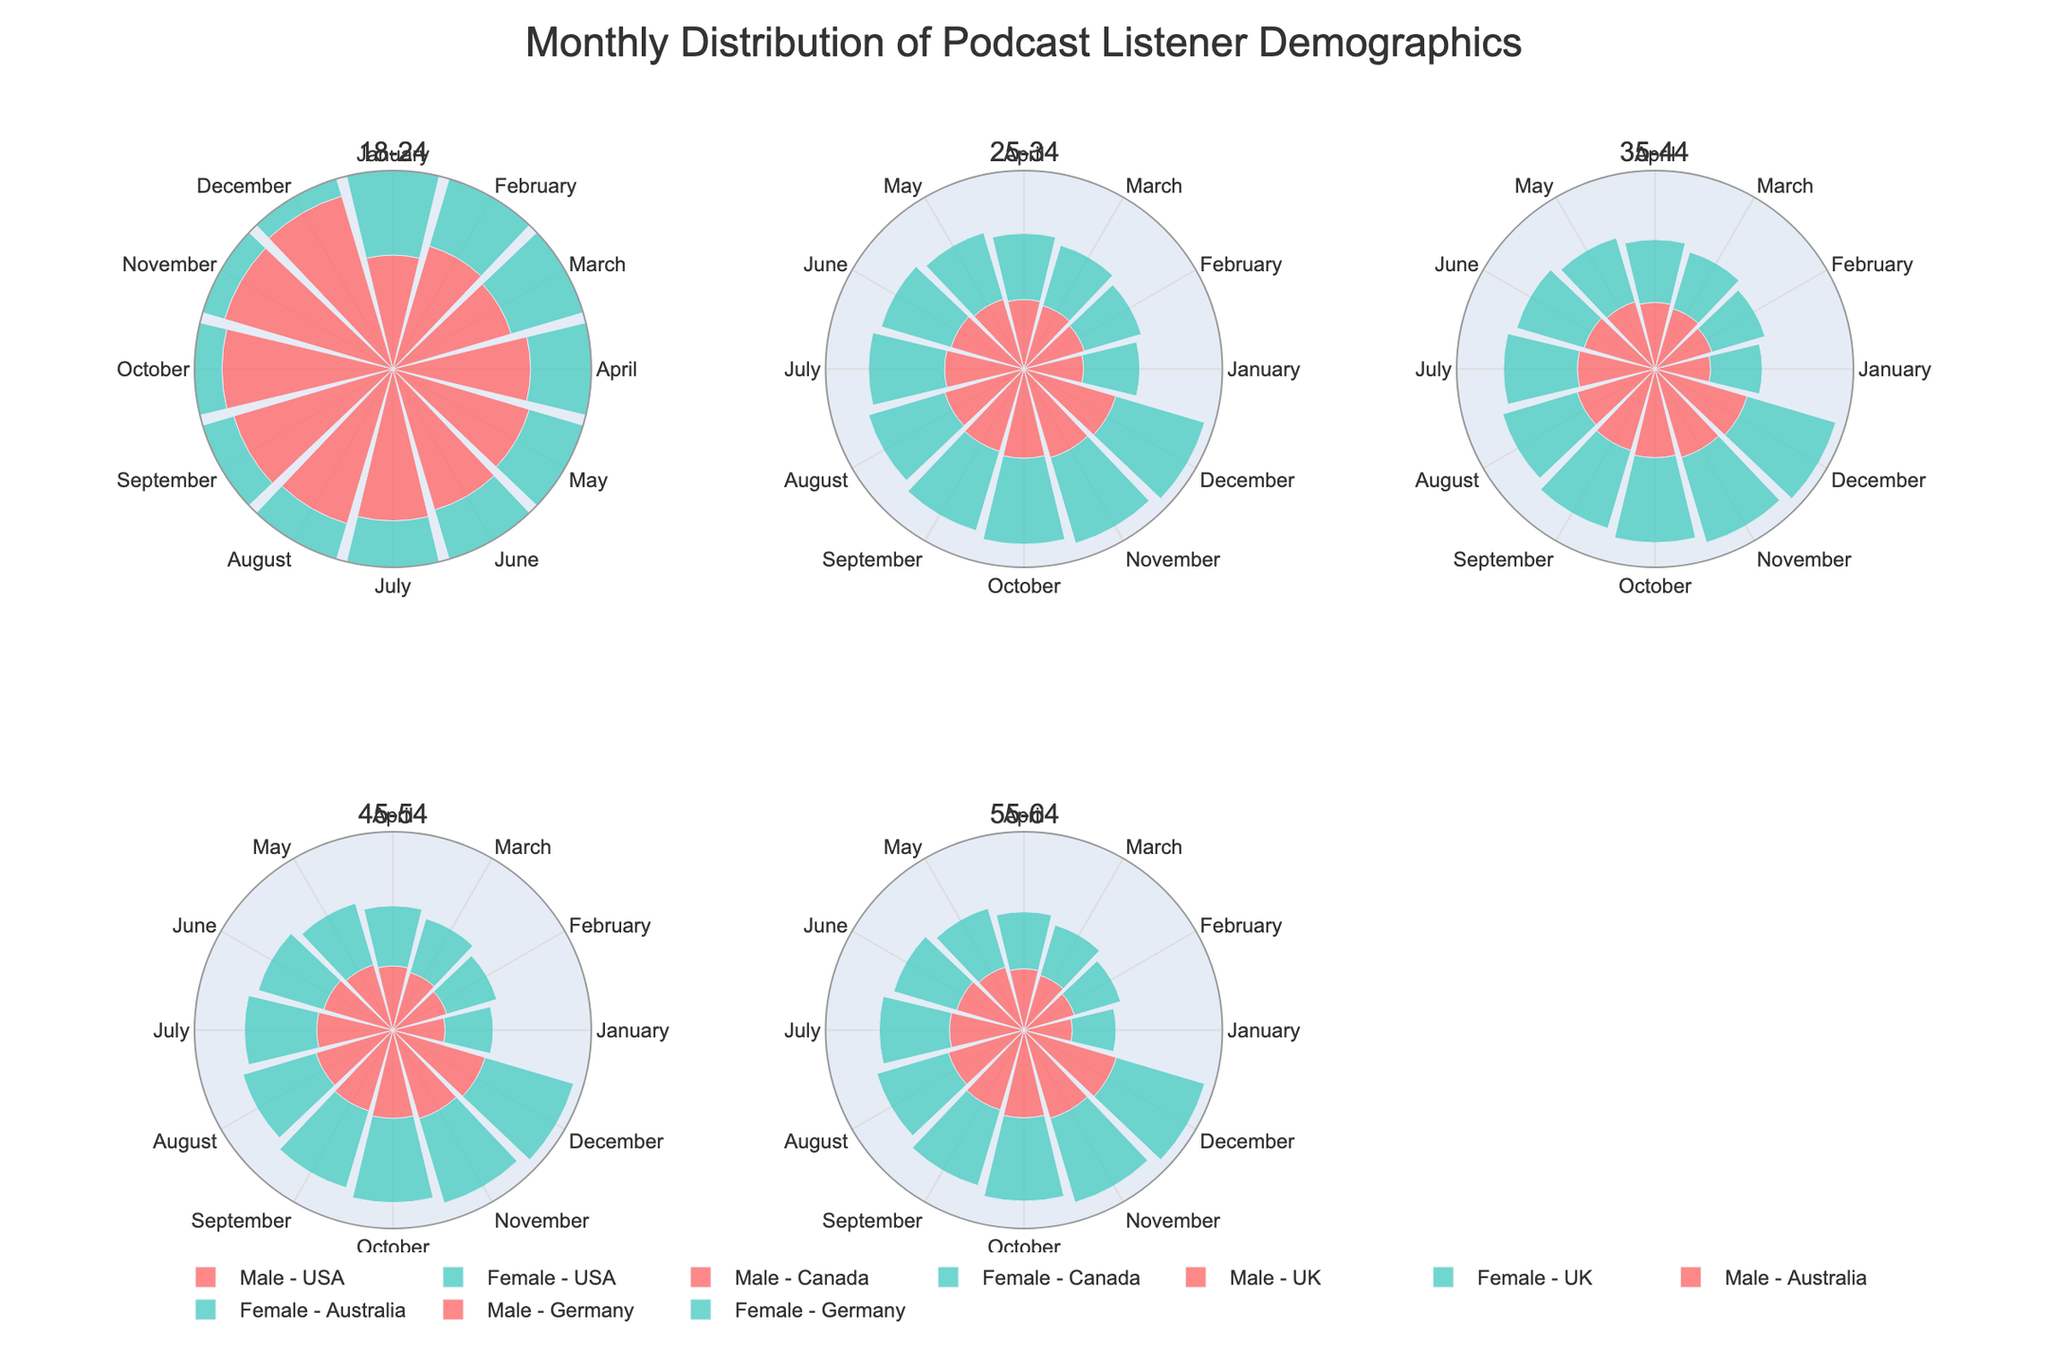What is the title of the figure? The title is typically found at the top of the figure and is intended to provide a brief description of the content. In this case, it is "Monthly Distribution of Podcast Listener Demographics."
Answer: Monthly Distribution of Podcast Listener Demographics How many rose charts are in the figure? There are individual rose charts for each age group, and since there are six age groups provided (18-24, 25-34, 35-44, 45-54, 55-64), the figure contains six rose charts. You can count each subplot indicated by the titles within the figure.
Answer: 6 Which age group has the highest count of male listeners in December? Check the subplot corresponding to each age group and look for the male count in December (the last bar in the polar plot). The age group 18-24 males in the USA has 190 listeners in December, which is the highest value.
Answer: 18-24 What is the trend in the number of podcast listeners for females in the 25-34 age group in Canada throughout the year? Observe the rose chart for the 25-34 age group and the bars representing female listeners in Canada. The trend shows a consistent increase in the number of listeners from January to December.
Answer: Increasing Which gender has more listeners in the 45-54 age group in Australia during June? Look at the 45-54 age group rose chart, then focus on the bars for June. Compare both genders in the chart. The male listeners in June (90) are higher than female listeners (85).
Answer: Male What are the colors used to represent male and female listeners in the charts? The colors are used consistently across all subplots; typically, you need to refer to the figure legend to identify them. Males are represented by a pinkish color and females by a light teal color.
Answer: Pink and Teal How do the listener numbers for 55-64 females in Germany change from January to December? Observe the subplot for the 55-64 age group and focus on the female listeners in Germany. Note each month's bar height from January to December, which shows a continuous increase from 50 in January to 105 in December.
Answer: Increasing Which age group shows the least variation in listener numbers throughout the year? Examine all the rose charts and assess the spread of listener numbers across the months. The 45-54 age group has relatively minimal variation compared to others. Both male and female counts show a steady increase but not dramatic changes.
Answer: 45-54 What is the monthly distribution for male listeners in the 35-44 age group in the UK? Look at the subplot for the 35-44 age group and check the pink bars, which represent male listeners in the UK. Note the heights of these bars for each month from January to December, ranging from 75 to 130 listeners.
Answer: 75 to 130 listeners 